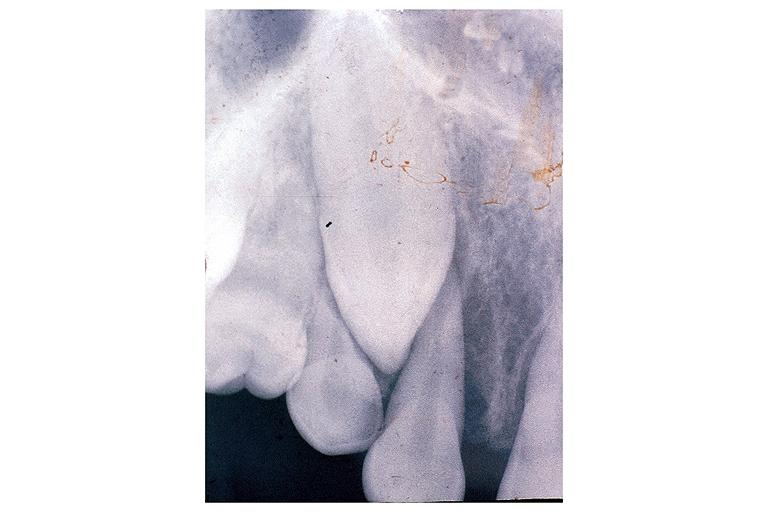where is this?
Answer the question using a single word or phrase. Oral 